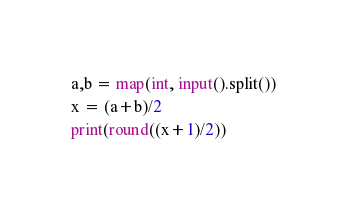Convert code to text. <code><loc_0><loc_0><loc_500><loc_500><_Python_>a,b = map(int, input().split())
x = (a+b)/2
print(round((x+1)/2))</code> 